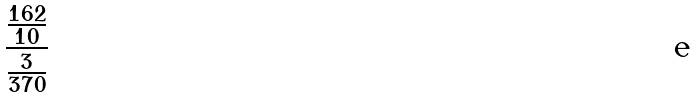<formula> <loc_0><loc_0><loc_500><loc_500>\frac { \frac { 1 6 2 } { 1 0 } } { \frac { 3 } { 3 7 0 } }</formula> 